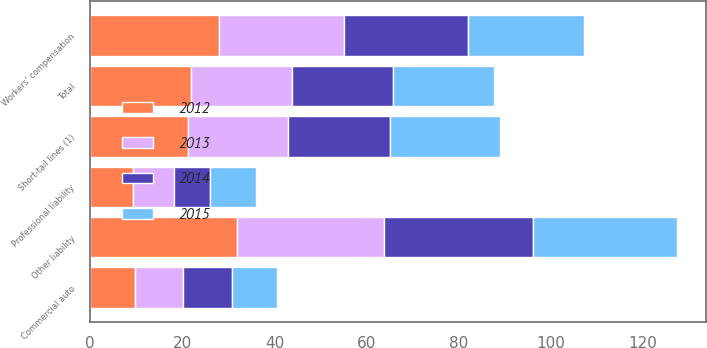Convert chart. <chart><loc_0><loc_0><loc_500><loc_500><stacked_bar_chart><ecel><fcel>Other liability<fcel>Workers' compensation<fcel>Short-tail lines (1)<fcel>Professional liability<fcel>Commercial auto<fcel>Total<nl><fcel>2015<fcel>31.3<fcel>25.1<fcel>23.9<fcel>10<fcel>9.7<fcel>21.9<nl><fcel>2012<fcel>31.8<fcel>27.9<fcel>21.2<fcel>9.4<fcel>9.7<fcel>21.9<nl><fcel>2013<fcel>31.9<fcel>27.2<fcel>21.8<fcel>8.7<fcel>10.4<fcel>21.9<nl><fcel>2014<fcel>32.4<fcel>27<fcel>22<fcel>7.9<fcel>10.7<fcel>21.9<nl></chart> 